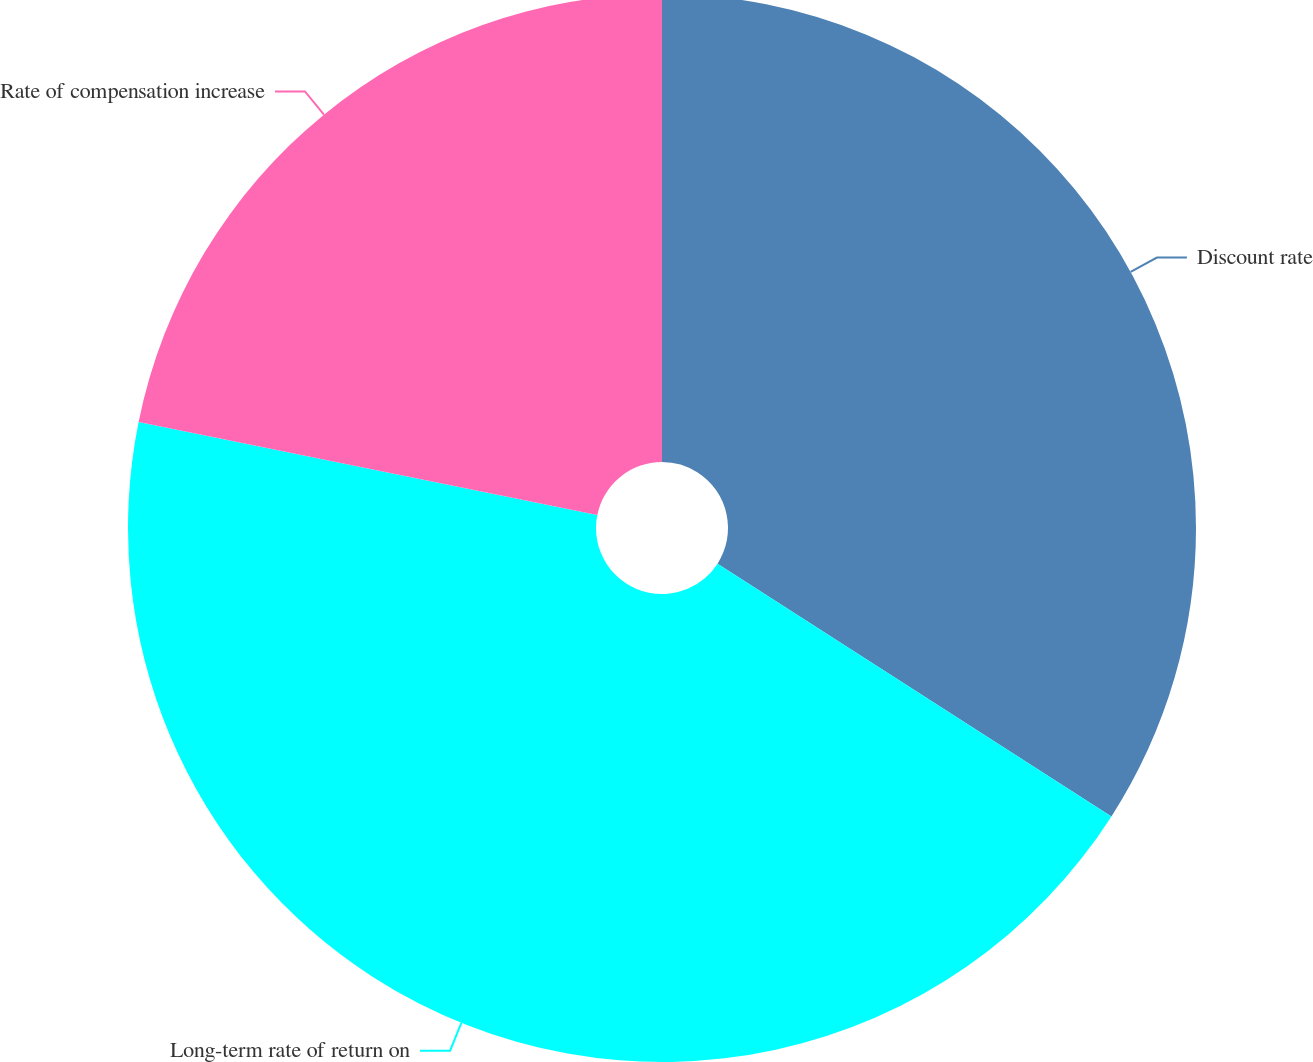Convert chart. <chart><loc_0><loc_0><loc_500><loc_500><pie_chart><fcel>Discount rate<fcel>Long-term rate of return on<fcel>Rate of compensation increase<nl><fcel>34.08%<fcel>44.1%<fcel>21.82%<nl></chart> 